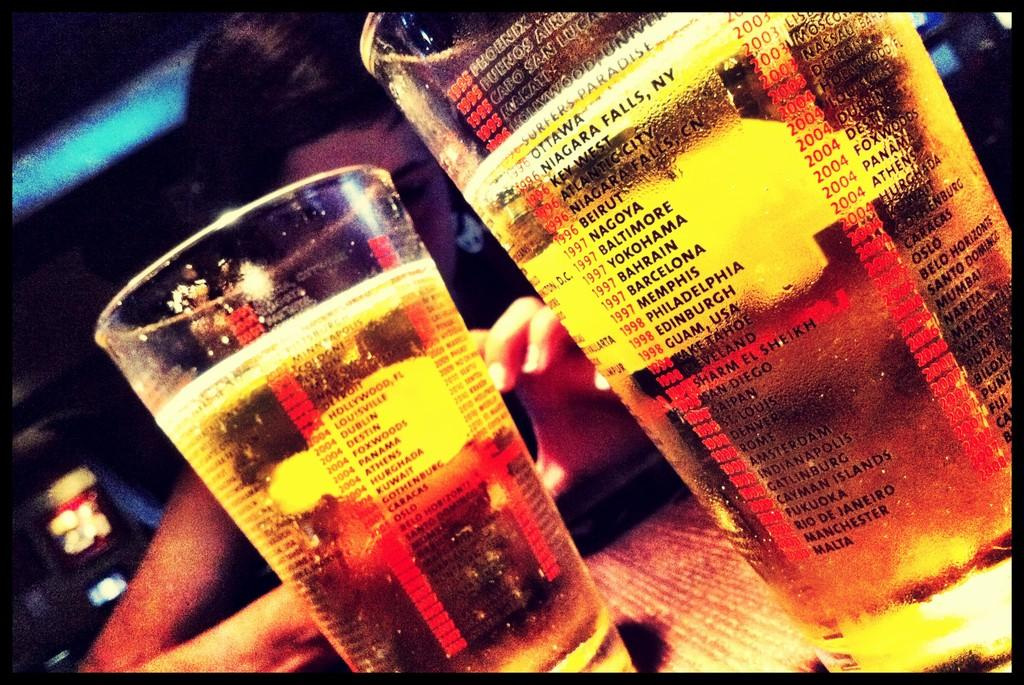What objects can be seen in the foreground of the image? There are two glasses in the foreground of the image. What can be seen in the background of the image? There are lights and a person in the background of the image. How many knots are tied on the dock in the image? There is no dock or knots present in the image. What type of parcel is being delivered by the person in the image? There is no parcel visible in the image, and the person's actions are not described. 